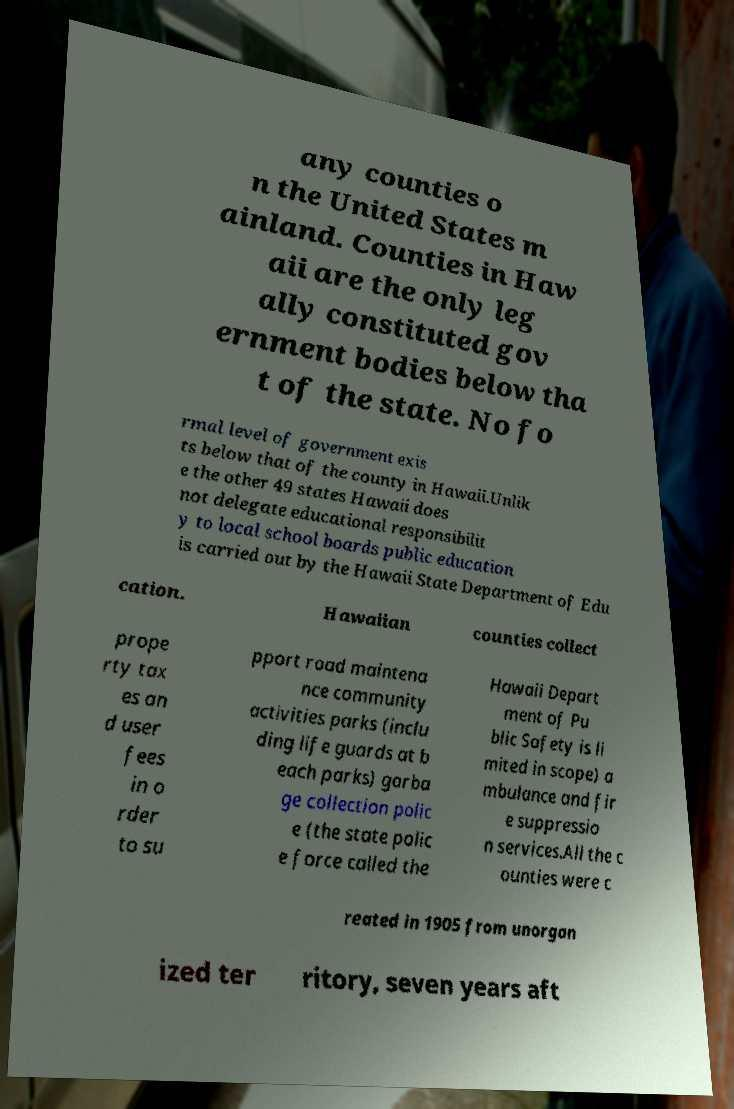For documentation purposes, I need the text within this image transcribed. Could you provide that? any counties o n the United States m ainland. Counties in Haw aii are the only leg ally constituted gov ernment bodies below tha t of the state. No fo rmal level of government exis ts below that of the county in Hawaii.Unlik e the other 49 states Hawaii does not delegate educational responsibilit y to local school boards public education is carried out by the Hawaii State Department of Edu cation. Hawaiian counties collect prope rty tax es an d user fees in o rder to su pport road maintena nce community activities parks (inclu ding life guards at b each parks) garba ge collection polic e (the state polic e force called the Hawaii Depart ment of Pu blic Safety is li mited in scope) a mbulance and fir e suppressio n services.All the c ounties were c reated in 1905 from unorgan ized ter ritory, seven years aft 